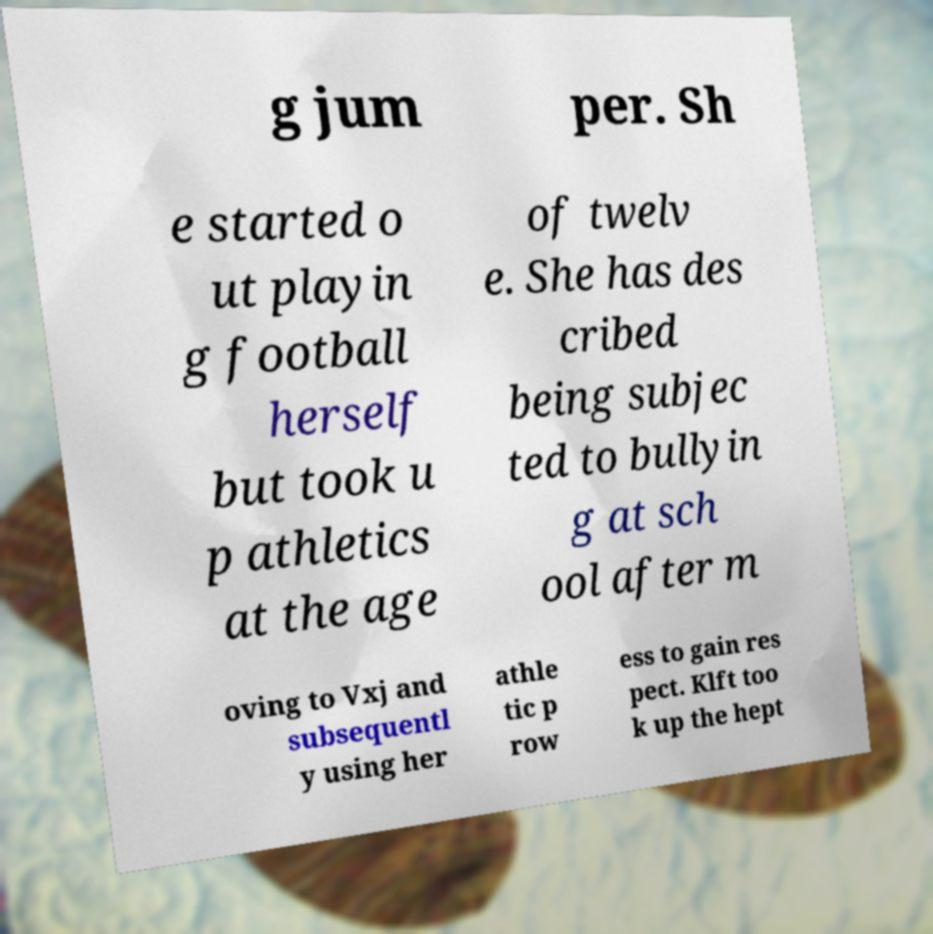For documentation purposes, I need the text within this image transcribed. Could you provide that? g jum per. Sh e started o ut playin g football herself but took u p athletics at the age of twelv e. She has des cribed being subjec ted to bullyin g at sch ool after m oving to Vxj and subsequentl y using her athle tic p row ess to gain res pect. Klft too k up the hept 